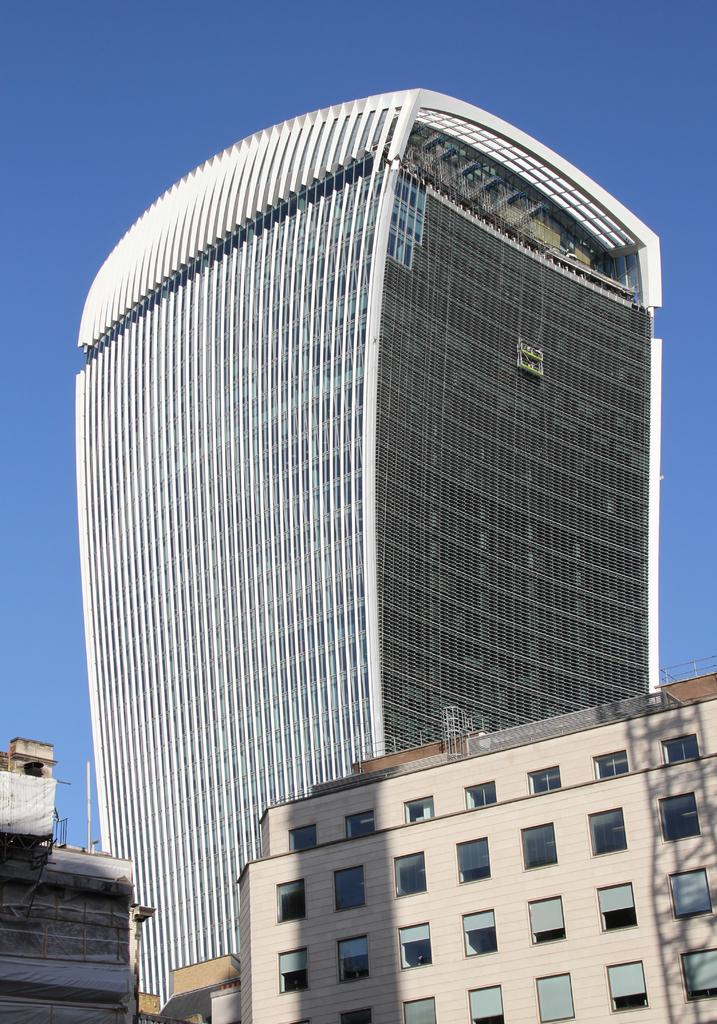What is the main subject in the center of the image? There are buildings in the center of the image. What can be seen at the top of the image? The sky is visible at the top of the image. What type of net is being used to catch the baseball in the image? There is no net or baseball present in the image; it only features buildings and the sky. 